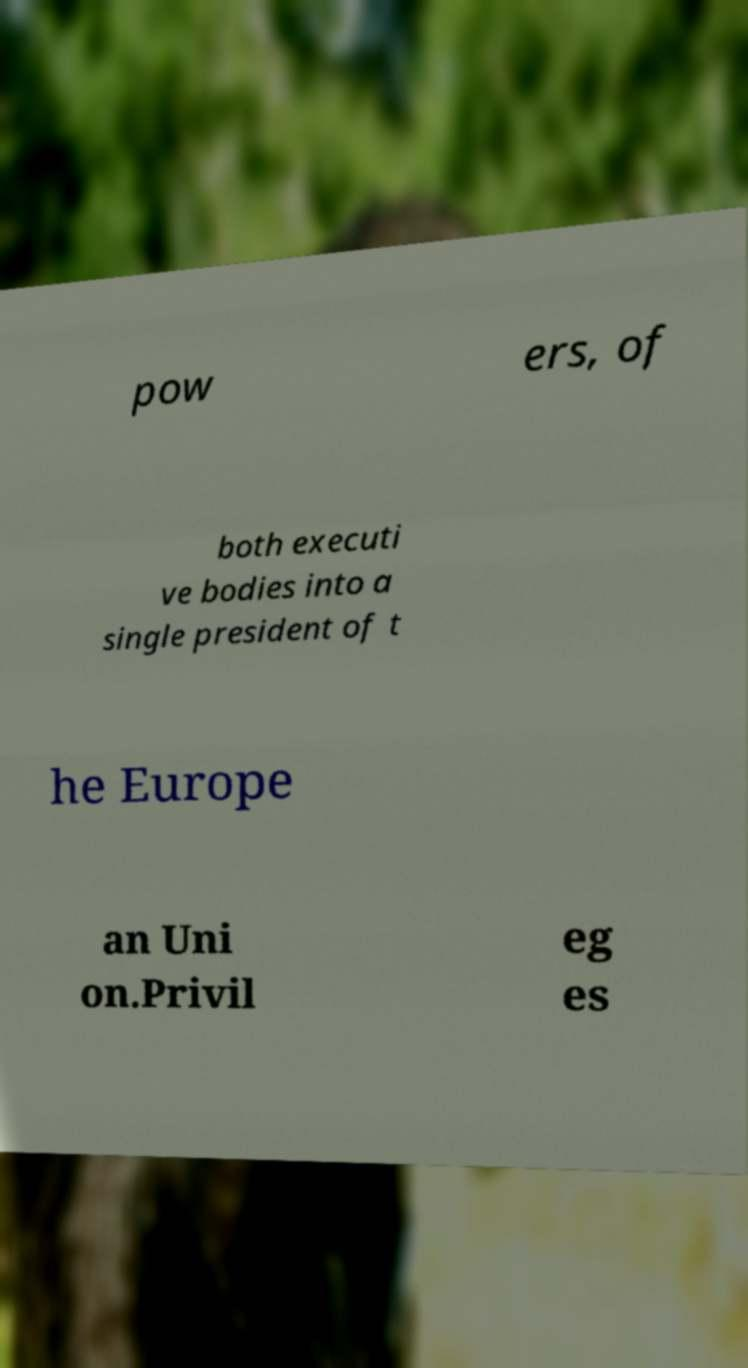Please identify and transcribe the text found in this image. pow ers, of both executi ve bodies into a single president of t he Europe an Uni on.Privil eg es 